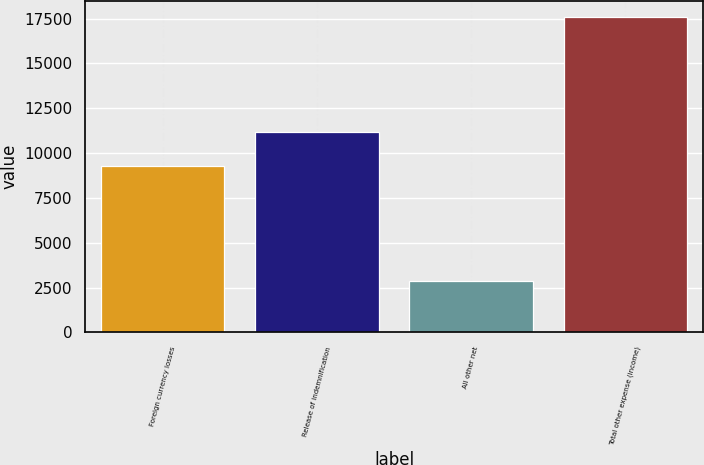Convert chart to OTSL. <chart><loc_0><loc_0><loc_500><loc_500><bar_chart><fcel>Foreign currency losses<fcel>Release of indemnification<fcel>All other net<fcel>Total other expense (income)<nl><fcel>9295<fcel>11180<fcel>2856<fcel>17619<nl></chart> 